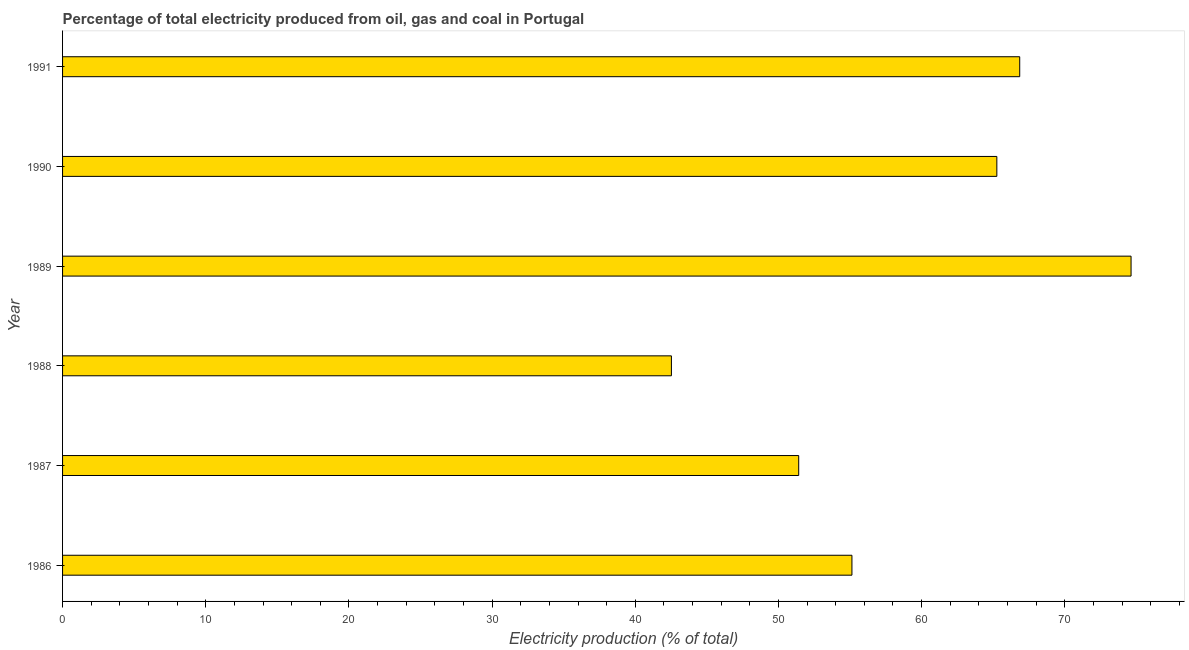What is the title of the graph?
Keep it short and to the point. Percentage of total electricity produced from oil, gas and coal in Portugal. What is the label or title of the X-axis?
Your answer should be compact. Electricity production (% of total). What is the label or title of the Y-axis?
Your answer should be compact. Year. What is the electricity production in 1990?
Your answer should be compact. 65.25. Across all years, what is the maximum electricity production?
Your answer should be very brief. 74.63. Across all years, what is the minimum electricity production?
Provide a succinct answer. 42.52. In which year was the electricity production minimum?
Offer a terse response. 1988. What is the sum of the electricity production?
Your answer should be compact. 355.81. What is the difference between the electricity production in 1988 and 1991?
Keep it short and to the point. -24.33. What is the average electricity production per year?
Ensure brevity in your answer.  59.3. What is the median electricity production?
Your response must be concise. 60.19. Do a majority of the years between 1987 and 1989 (inclusive) have electricity production greater than 60 %?
Give a very brief answer. No. What is the ratio of the electricity production in 1986 to that in 1987?
Provide a succinct answer. 1.07. Is the electricity production in 1988 less than that in 1990?
Provide a short and direct response. Yes. Is the difference between the electricity production in 1987 and 1989 greater than the difference between any two years?
Give a very brief answer. No. What is the difference between the highest and the second highest electricity production?
Provide a succinct answer. 7.78. What is the difference between the highest and the lowest electricity production?
Offer a very short reply. 32.1. What is the difference between two consecutive major ticks on the X-axis?
Offer a very short reply. 10. Are the values on the major ticks of X-axis written in scientific E-notation?
Your answer should be compact. No. What is the Electricity production (% of total) of 1986?
Your answer should be very brief. 55.13. What is the Electricity production (% of total) in 1987?
Make the answer very short. 51.42. What is the Electricity production (% of total) in 1988?
Provide a short and direct response. 42.52. What is the Electricity production (% of total) of 1989?
Your response must be concise. 74.63. What is the Electricity production (% of total) in 1990?
Give a very brief answer. 65.25. What is the Electricity production (% of total) of 1991?
Offer a terse response. 66.85. What is the difference between the Electricity production (% of total) in 1986 and 1987?
Your answer should be very brief. 3.72. What is the difference between the Electricity production (% of total) in 1986 and 1988?
Your answer should be very brief. 12.61. What is the difference between the Electricity production (% of total) in 1986 and 1989?
Give a very brief answer. -19.5. What is the difference between the Electricity production (% of total) in 1986 and 1990?
Offer a terse response. -10.12. What is the difference between the Electricity production (% of total) in 1986 and 1991?
Ensure brevity in your answer.  -11.72. What is the difference between the Electricity production (% of total) in 1987 and 1988?
Your answer should be very brief. 8.89. What is the difference between the Electricity production (% of total) in 1987 and 1989?
Ensure brevity in your answer.  -23.21. What is the difference between the Electricity production (% of total) in 1987 and 1990?
Offer a very short reply. -13.84. What is the difference between the Electricity production (% of total) in 1987 and 1991?
Give a very brief answer. -15.44. What is the difference between the Electricity production (% of total) in 1988 and 1989?
Your answer should be compact. -32.1. What is the difference between the Electricity production (% of total) in 1988 and 1990?
Provide a short and direct response. -22.73. What is the difference between the Electricity production (% of total) in 1988 and 1991?
Keep it short and to the point. -24.33. What is the difference between the Electricity production (% of total) in 1989 and 1990?
Keep it short and to the point. 9.37. What is the difference between the Electricity production (% of total) in 1989 and 1991?
Provide a short and direct response. 7.78. What is the difference between the Electricity production (% of total) in 1990 and 1991?
Provide a succinct answer. -1.6. What is the ratio of the Electricity production (% of total) in 1986 to that in 1987?
Offer a terse response. 1.07. What is the ratio of the Electricity production (% of total) in 1986 to that in 1988?
Offer a terse response. 1.3. What is the ratio of the Electricity production (% of total) in 1986 to that in 1989?
Your answer should be compact. 0.74. What is the ratio of the Electricity production (% of total) in 1986 to that in 1990?
Offer a very short reply. 0.84. What is the ratio of the Electricity production (% of total) in 1986 to that in 1991?
Make the answer very short. 0.82. What is the ratio of the Electricity production (% of total) in 1987 to that in 1988?
Your response must be concise. 1.21. What is the ratio of the Electricity production (% of total) in 1987 to that in 1989?
Make the answer very short. 0.69. What is the ratio of the Electricity production (% of total) in 1987 to that in 1990?
Your answer should be compact. 0.79. What is the ratio of the Electricity production (% of total) in 1987 to that in 1991?
Keep it short and to the point. 0.77. What is the ratio of the Electricity production (% of total) in 1988 to that in 1989?
Provide a succinct answer. 0.57. What is the ratio of the Electricity production (% of total) in 1988 to that in 1990?
Your response must be concise. 0.65. What is the ratio of the Electricity production (% of total) in 1988 to that in 1991?
Your response must be concise. 0.64. What is the ratio of the Electricity production (% of total) in 1989 to that in 1990?
Offer a very short reply. 1.14. What is the ratio of the Electricity production (% of total) in 1989 to that in 1991?
Offer a very short reply. 1.12. 